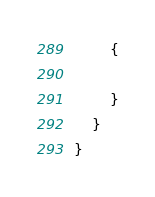Convert code to text. <code><loc_0><loc_0><loc_500><loc_500><_C#_>        {

        }
    }
}</code> 